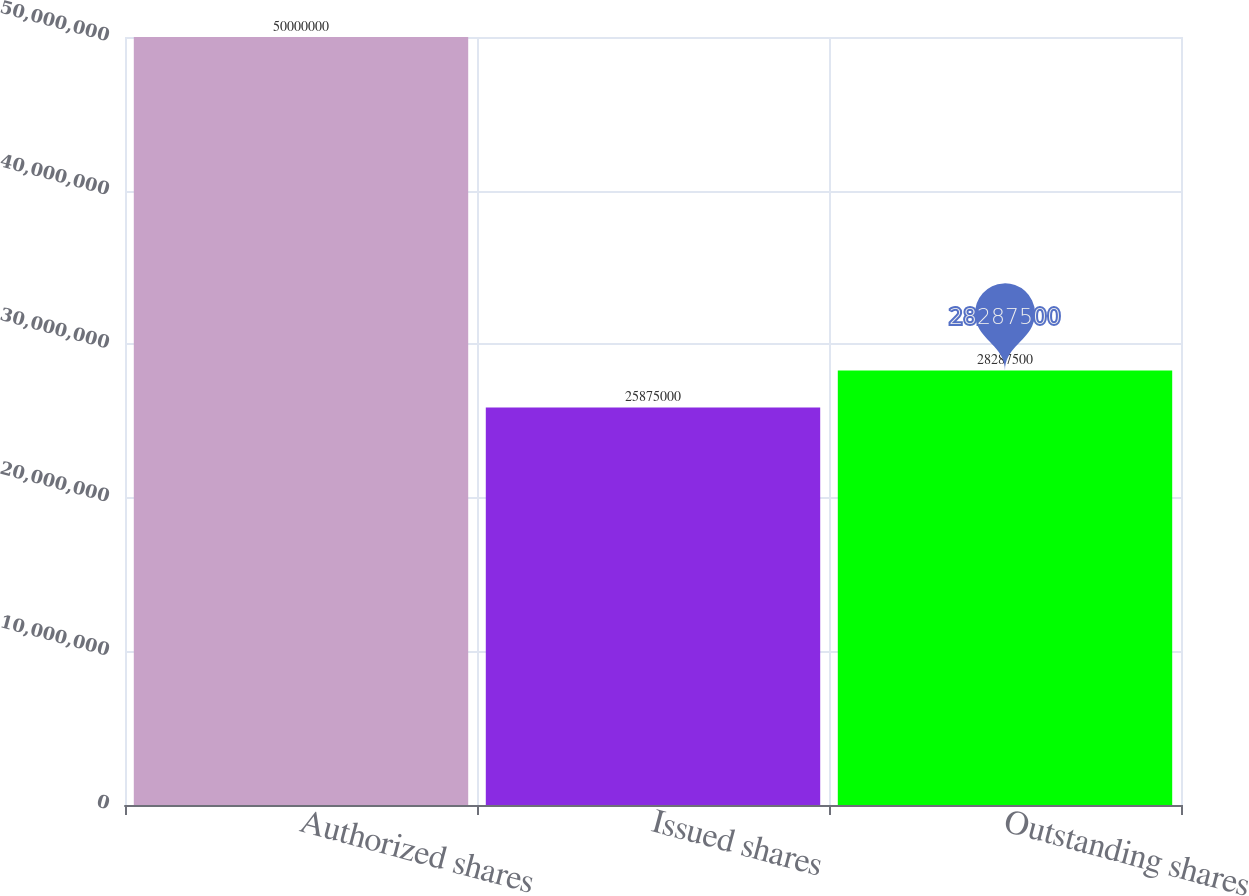Convert chart to OTSL. <chart><loc_0><loc_0><loc_500><loc_500><bar_chart><fcel>Authorized shares<fcel>Issued shares<fcel>Outstanding shares<nl><fcel>5e+07<fcel>2.5875e+07<fcel>2.82875e+07<nl></chart> 